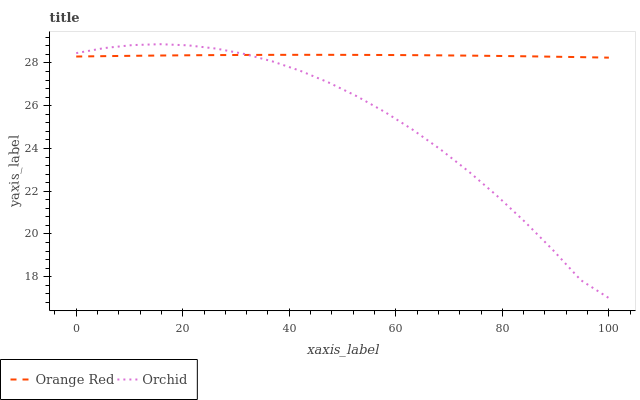Does Orchid have the minimum area under the curve?
Answer yes or no. Yes. Does Orange Red have the maximum area under the curve?
Answer yes or no. Yes. Does Orchid have the maximum area under the curve?
Answer yes or no. No. Is Orange Red the smoothest?
Answer yes or no. Yes. Is Orchid the roughest?
Answer yes or no. Yes. Is Orchid the smoothest?
Answer yes or no. No. Does Orchid have the lowest value?
Answer yes or no. Yes. Does Orchid have the highest value?
Answer yes or no. Yes. Does Orchid intersect Orange Red?
Answer yes or no. Yes. Is Orchid less than Orange Red?
Answer yes or no. No. Is Orchid greater than Orange Red?
Answer yes or no. No. 